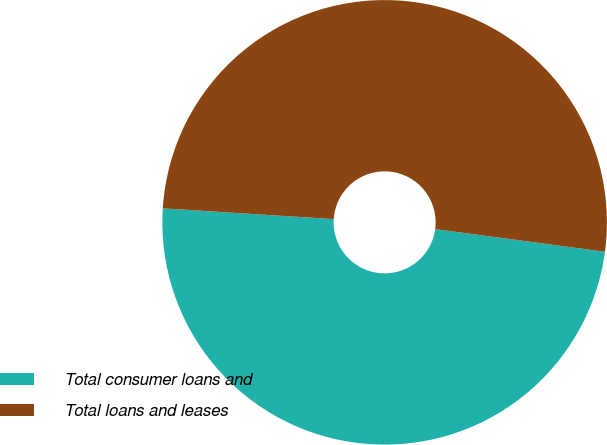Convert chart. <chart><loc_0><loc_0><loc_500><loc_500><pie_chart><fcel>Total consumer loans and<fcel>Total loans and leases<nl><fcel>48.89%<fcel>51.11%<nl></chart> 